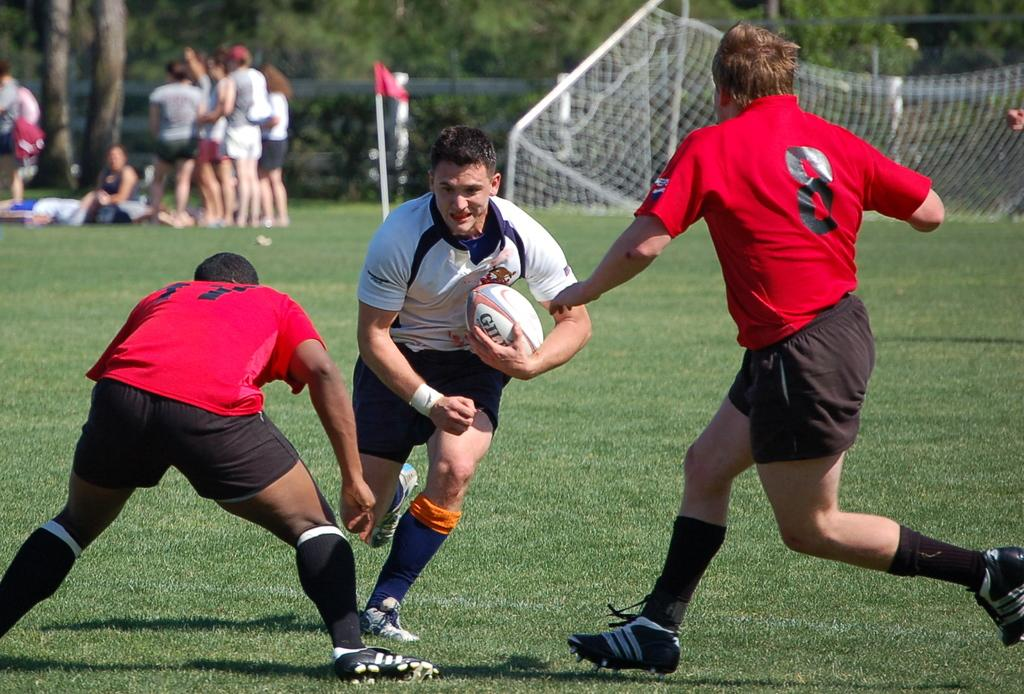Who is present in the image? There are people in the image. What is the man holding in the image? The man is holding a ball. Can you describe the people in the background of the image? There are people standing in the background of the image. What can be seen in the background of the image besides people? There is a flag and a tree in the background of the image. What type of furniture is being balanced by the people in the image? There is no furniture present in the image, and therefore no balancing act is taking place. 